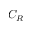<formula> <loc_0><loc_0><loc_500><loc_500>C _ { R }</formula> 